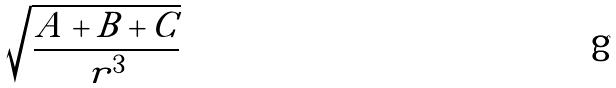<formula> <loc_0><loc_0><loc_500><loc_500>\sqrt { \frac { A + B + C } { r ^ { 3 } } }</formula> 